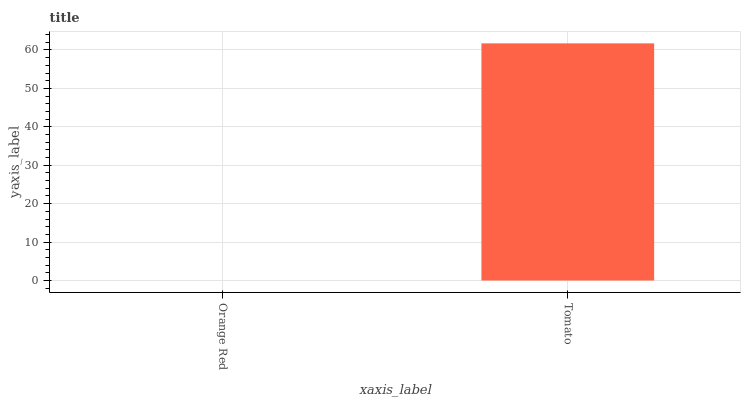Is Orange Red the minimum?
Answer yes or no. Yes. Is Tomato the maximum?
Answer yes or no. Yes. Is Tomato the minimum?
Answer yes or no. No. Is Tomato greater than Orange Red?
Answer yes or no. Yes. Is Orange Red less than Tomato?
Answer yes or no. Yes. Is Orange Red greater than Tomato?
Answer yes or no. No. Is Tomato less than Orange Red?
Answer yes or no. No. Is Tomato the high median?
Answer yes or no. Yes. Is Orange Red the low median?
Answer yes or no. Yes. Is Orange Red the high median?
Answer yes or no. No. Is Tomato the low median?
Answer yes or no. No. 